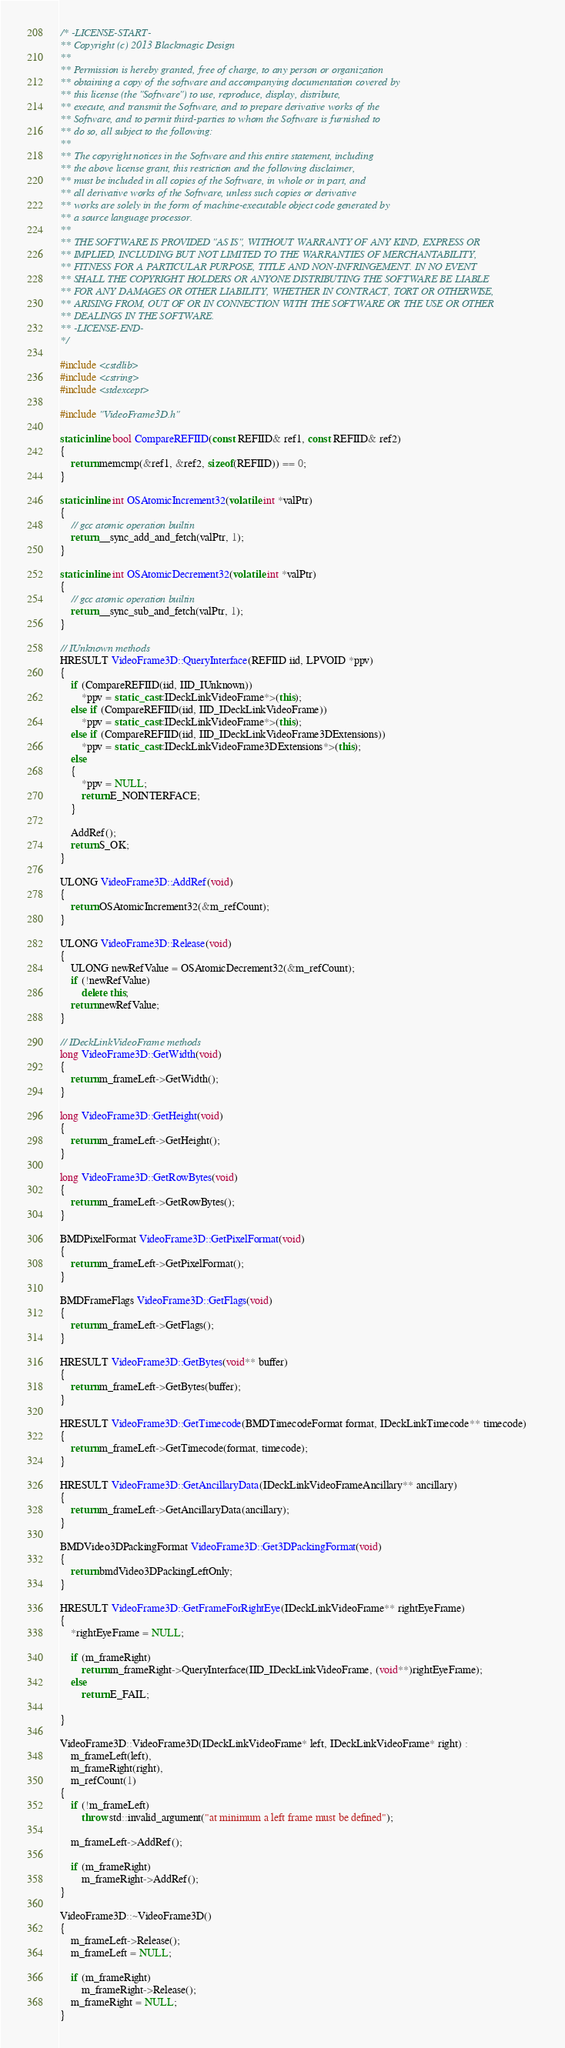Convert code to text. <code><loc_0><loc_0><loc_500><loc_500><_C++_>/* -LICENSE-START-
** Copyright (c) 2013 Blackmagic Design
**
** Permission is hereby granted, free of charge, to any person or organization
** obtaining a copy of the software and accompanying documentation covered by
** this license (the "Software") to use, reproduce, display, distribute,
** execute, and transmit the Software, and to prepare derivative works of the
** Software, and to permit third-parties to whom the Software is furnished to
** do so, all subject to the following:
**
** The copyright notices in the Software and this entire statement, including
** the above license grant, this restriction and the following disclaimer,
** must be included in all copies of the Software, in whole or in part, and
** all derivative works of the Software, unless such copies or derivative
** works are solely in the form of machine-executable object code generated by
** a source language processor.
**
** THE SOFTWARE IS PROVIDED "AS IS", WITHOUT WARRANTY OF ANY KIND, EXPRESS OR
** IMPLIED, INCLUDING BUT NOT LIMITED TO THE WARRANTIES OF MERCHANTABILITY,
** FITNESS FOR A PARTICULAR PURPOSE, TITLE AND NON-INFRINGEMENT. IN NO EVENT
** SHALL THE COPYRIGHT HOLDERS OR ANYONE DISTRIBUTING THE SOFTWARE BE LIABLE
** FOR ANY DAMAGES OR OTHER LIABILITY, WHETHER IN CONTRACT, TORT OR OTHERWISE,
** ARISING FROM, OUT OF OR IN CONNECTION WITH THE SOFTWARE OR THE USE OR OTHER
** DEALINGS IN THE SOFTWARE.
** -LICENSE-END-
*/

#include <cstdlib>
#include <cstring>
#include <stdexcept>

#include "VideoFrame3D.h"

static inline bool CompareREFIID(const REFIID& ref1, const REFIID& ref2)
{
	return memcmp(&ref1, &ref2, sizeof(REFIID)) == 0;
}

static inline int OSAtomicIncrement32(volatile int *valPtr)
{
	// gcc atomic operation builtin
	return __sync_add_and_fetch(valPtr, 1);
}

static inline int OSAtomicDecrement32(volatile int *valPtr)
{
	// gcc atomic operation builtin
	return __sync_sub_and_fetch(valPtr, 1);
}

// IUnknown methods
HRESULT VideoFrame3D::QueryInterface(REFIID iid, LPVOID *ppv)
{
	if (CompareREFIID(iid, IID_IUnknown))
		*ppv = static_cast<IDeckLinkVideoFrame*>(this);
	else if (CompareREFIID(iid, IID_IDeckLinkVideoFrame))
		*ppv = static_cast<IDeckLinkVideoFrame*>(this);
	else if (CompareREFIID(iid, IID_IDeckLinkVideoFrame3DExtensions))
		*ppv = static_cast<IDeckLinkVideoFrame3DExtensions*>(this);
	else
	{
		*ppv = NULL;
		return E_NOINTERFACE;
	}

	AddRef();
	return S_OK;
}

ULONG VideoFrame3D::AddRef(void)
{
	return OSAtomicIncrement32(&m_refCount);
}

ULONG VideoFrame3D::Release(void)
{
	ULONG newRefValue = OSAtomicDecrement32(&m_refCount);
	if (!newRefValue)
		delete this;
	return newRefValue;
}

// IDeckLinkVideoFrame methods
long VideoFrame3D::GetWidth(void)
{
	return m_frameLeft->GetWidth();
}

long VideoFrame3D::GetHeight(void)
{
	return m_frameLeft->GetHeight();
}

long VideoFrame3D::GetRowBytes(void)
{
	return m_frameLeft->GetRowBytes();
}

BMDPixelFormat VideoFrame3D::GetPixelFormat(void)
{
	return m_frameLeft->GetPixelFormat();
}

BMDFrameFlags VideoFrame3D::GetFlags(void)
{
	return m_frameLeft->GetFlags();
}

HRESULT VideoFrame3D::GetBytes(void** buffer)
{
	return m_frameLeft->GetBytes(buffer);
}

HRESULT VideoFrame3D::GetTimecode(BMDTimecodeFormat format, IDeckLinkTimecode** timecode)
{
	return m_frameLeft->GetTimecode(format, timecode);
}

HRESULT VideoFrame3D::GetAncillaryData(IDeckLinkVideoFrameAncillary** ancillary)
{
	return m_frameLeft->GetAncillaryData(ancillary);
}

BMDVideo3DPackingFormat VideoFrame3D::Get3DPackingFormat(void)
{
	return bmdVideo3DPackingLeftOnly;
}

HRESULT VideoFrame3D::GetFrameForRightEye(IDeckLinkVideoFrame** rightEyeFrame)
{
	*rightEyeFrame = NULL;

	if (m_frameRight)
		return m_frameRight->QueryInterface(IID_IDeckLinkVideoFrame, (void**)rightEyeFrame);
	else
		return E_FAIL;

}

VideoFrame3D::VideoFrame3D(IDeckLinkVideoFrame* left, IDeckLinkVideoFrame* right) :
	m_frameLeft(left),
	m_frameRight(right),
	m_refCount(1)
{
	if (!m_frameLeft)
		throw std::invalid_argument("at minimum a left frame must be defined");

	m_frameLeft->AddRef();

	if (m_frameRight)
		m_frameRight->AddRef();
}

VideoFrame3D::~VideoFrame3D()
{
	m_frameLeft->Release();
	m_frameLeft = NULL;

	if (m_frameRight)
		m_frameRight->Release();
	m_frameRight = NULL;
}
</code> 